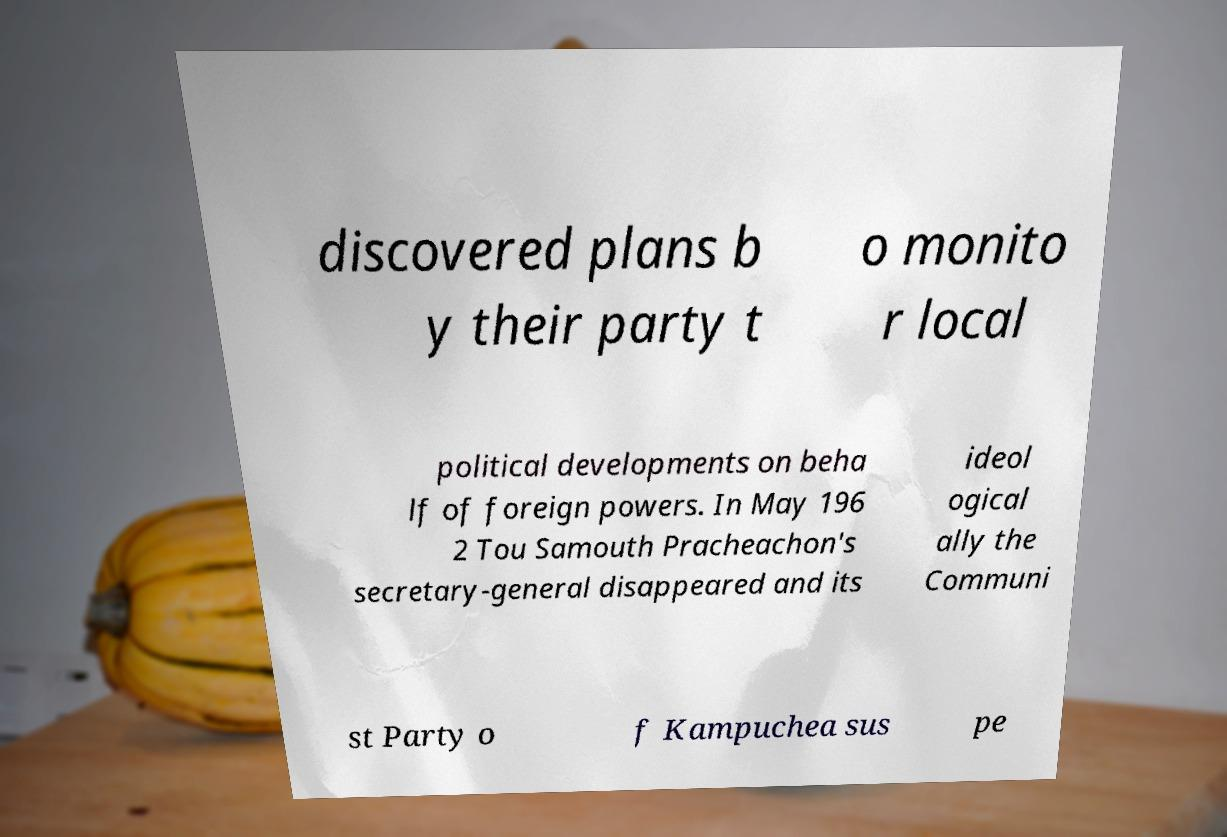Please identify and transcribe the text found in this image. discovered plans b y their party t o monito r local political developments on beha lf of foreign powers. In May 196 2 Tou Samouth Pracheachon's secretary-general disappeared and its ideol ogical ally the Communi st Party o f Kampuchea sus pe 